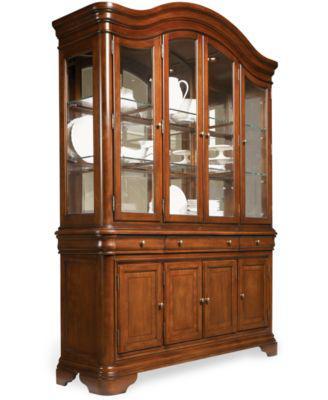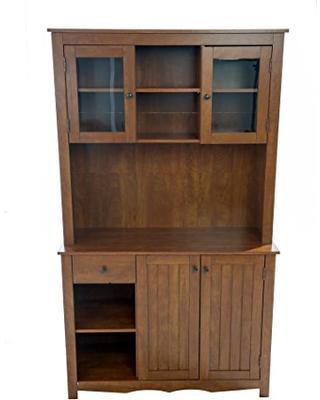The first image is the image on the left, the second image is the image on the right. For the images shown, is this caption "One of these images contains a completely empty hutch, and all of these images are on a plain white background." true? Answer yes or no. Yes. The first image is the image on the left, the second image is the image on the right. Considering the images on both sides, is "Brown cabinets are on a stark white background" valid? Answer yes or no. Yes. 